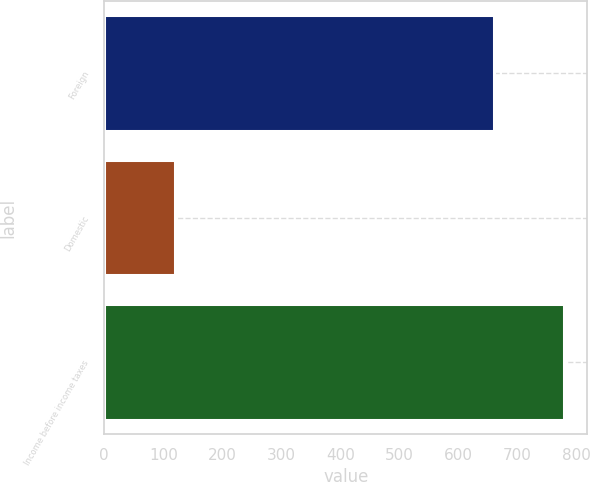Convert chart. <chart><loc_0><loc_0><loc_500><loc_500><bar_chart><fcel>Foreign<fcel>Domestic<fcel>Income before income taxes<nl><fcel>660<fcel>120<fcel>780<nl></chart> 